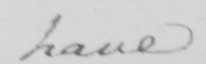Please provide the text content of this handwritten line. have 